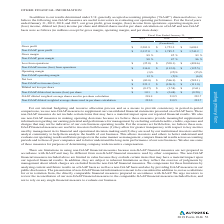Looking at Autodesk's financial data, please calculate: What is the average net restructing and exit costs over the 3 year period? To answer this question, I need to perform calculations using the financial data. The calculation is: (0.14+0.43+0.35)/3 , which equals 0.31. The key data points involved are: 0.14, 0.35, 0.43. Also, Why does the company exclude stock-based compensation expenses? Based on the financial document, the answer is We exclude stock-based compensation expenses from non-GAAP measures primarily because they are non-cash expenses and management finds it useful to exclude certain non-cash charges to assess the appropriate level of various operating expenses to assist in budgeting, planning and forecasting future periods.. Also, Why does the company exclude acquisition costs? Based on the financial document, the answer is We believe excluding acquisition related costs facilitates the comparison of our financial results to the Company's historical operating results and to other companies in our industry.. Also, How much was the stock-based compensation for the former CEOs' transition agreements? Based on the financial document, the answer is $16.4 million. Also, can you calculate: What is the difference between the non-GAAP diluted income per share and the diluted net  (loss) income per share in 2019? Based on the calculation: 1.01-(-0.37) , the result is 1.38. This is based on the information: "$ (106.3) $ (111.0) Diluted net loss per share $ (0.37) $ (2.58) $ (2.61) Non-GAAP diluted net income (loss) per share $ 1.01 $ (0.48) $ (0.50) GAAP dilut 1) Non-GAAP diluted net income (loss) per sha..." The key data points involved are: 0.37, 1.01. Also, can you calculate: What was the average stock-based compensation expense over the last 3 years? To answer this question, I need to perform calculations using the financial data. The calculation is: (1.12+1.11+1)/3 , which equals 1.08. The key data points involved are: 1.11, 1.12. 